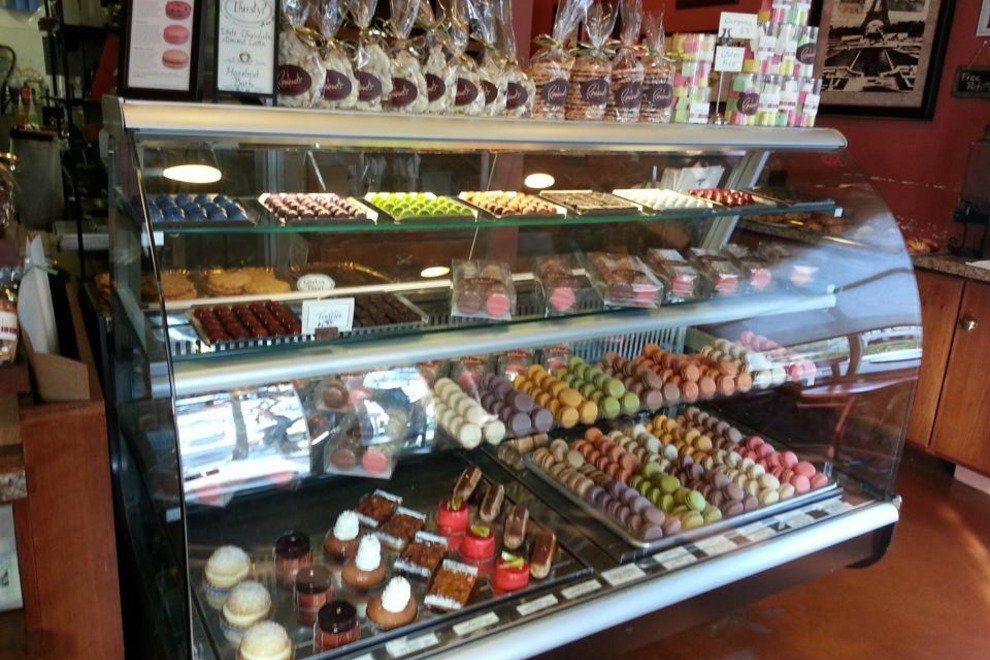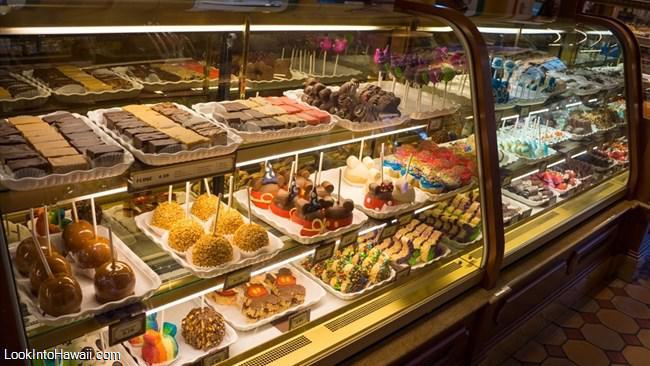The first image is the image on the left, the second image is the image on the right. For the images shown, is this caption "The right image shows a glass display case containing white trays of glazed and coated ball-shaped treats with stick handles." true? Answer yes or no. Yes. 